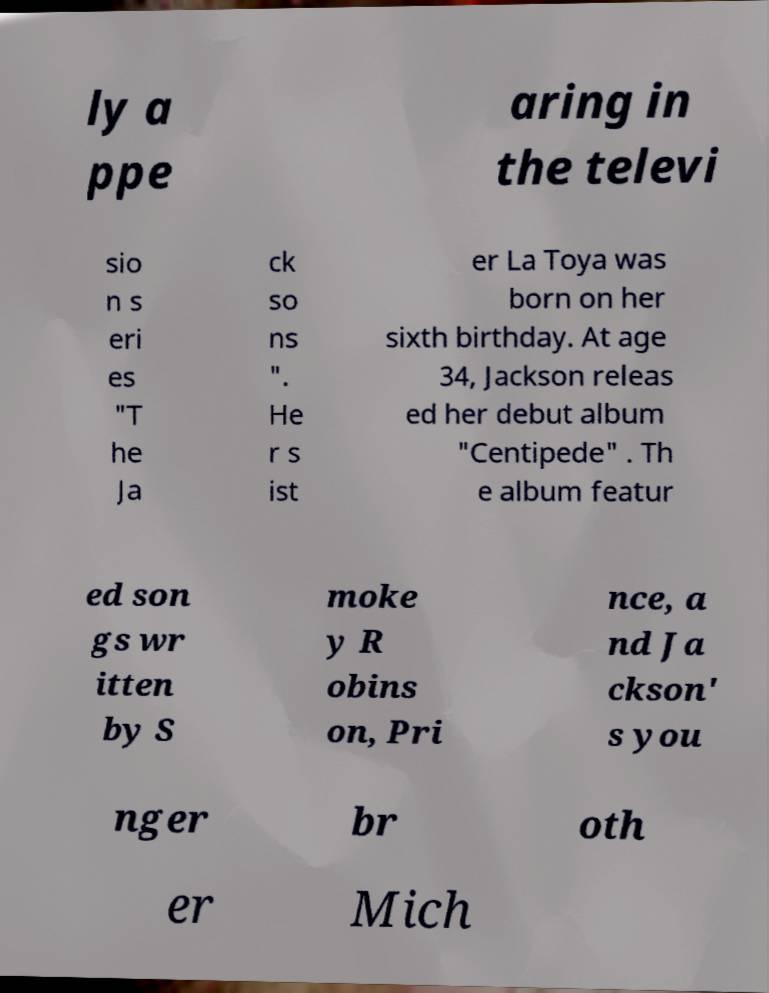Please read and relay the text visible in this image. What does it say? ly a ppe aring in the televi sio n s eri es "T he Ja ck so ns ". He r s ist er La Toya was born on her sixth birthday. At age 34, Jackson releas ed her debut album "Centipede" . Th e album featur ed son gs wr itten by S moke y R obins on, Pri nce, a nd Ja ckson' s you nger br oth er Mich 